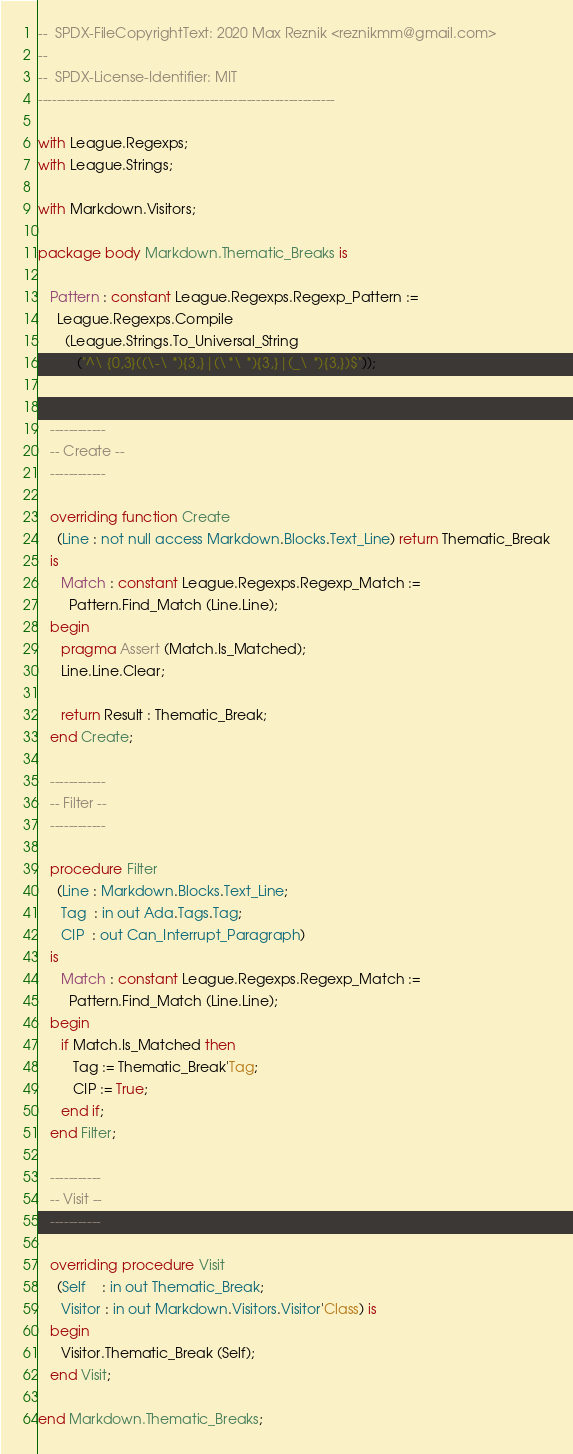<code> <loc_0><loc_0><loc_500><loc_500><_Ada_>--  SPDX-FileCopyrightText: 2020 Max Reznik <reznikmm@gmail.com>
--
--  SPDX-License-Identifier: MIT
----------------------------------------------------------------

with League.Regexps;
with League.Strings;

with Markdown.Visitors;

package body Markdown.Thematic_Breaks is

   Pattern : constant League.Regexps.Regexp_Pattern :=
     League.Regexps.Compile
       (League.Strings.To_Universal_String
          ("^\ {0,3}((\-\ *){3,}|(\*\ *){3,}|(_\ *){3,})$"));


   ------------
   -- Create --
   ------------

   overriding function Create
     (Line : not null access Markdown.Blocks.Text_Line) return Thematic_Break
   is
      Match : constant League.Regexps.Regexp_Match :=
        Pattern.Find_Match (Line.Line);
   begin
      pragma Assert (Match.Is_Matched);
      Line.Line.Clear;

      return Result : Thematic_Break;
   end Create;

   ------------
   -- Filter --
   ------------

   procedure Filter
     (Line : Markdown.Blocks.Text_Line;
      Tag  : in out Ada.Tags.Tag;
      CIP  : out Can_Interrupt_Paragraph)
   is
      Match : constant League.Regexps.Regexp_Match :=
        Pattern.Find_Match (Line.Line);
   begin
      if Match.Is_Matched then
         Tag := Thematic_Break'Tag;
         CIP := True;
      end if;
   end Filter;

   -----------
   -- Visit --
   -----------

   overriding procedure Visit
     (Self    : in out Thematic_Break;
      Visitor : in out Markdown.Visitors.Visitor'Class) is
   begin
      Visitor.Thematic_Break (Self);
   end Visit;

end Markdown.Thematic_Breaks;
</code> 